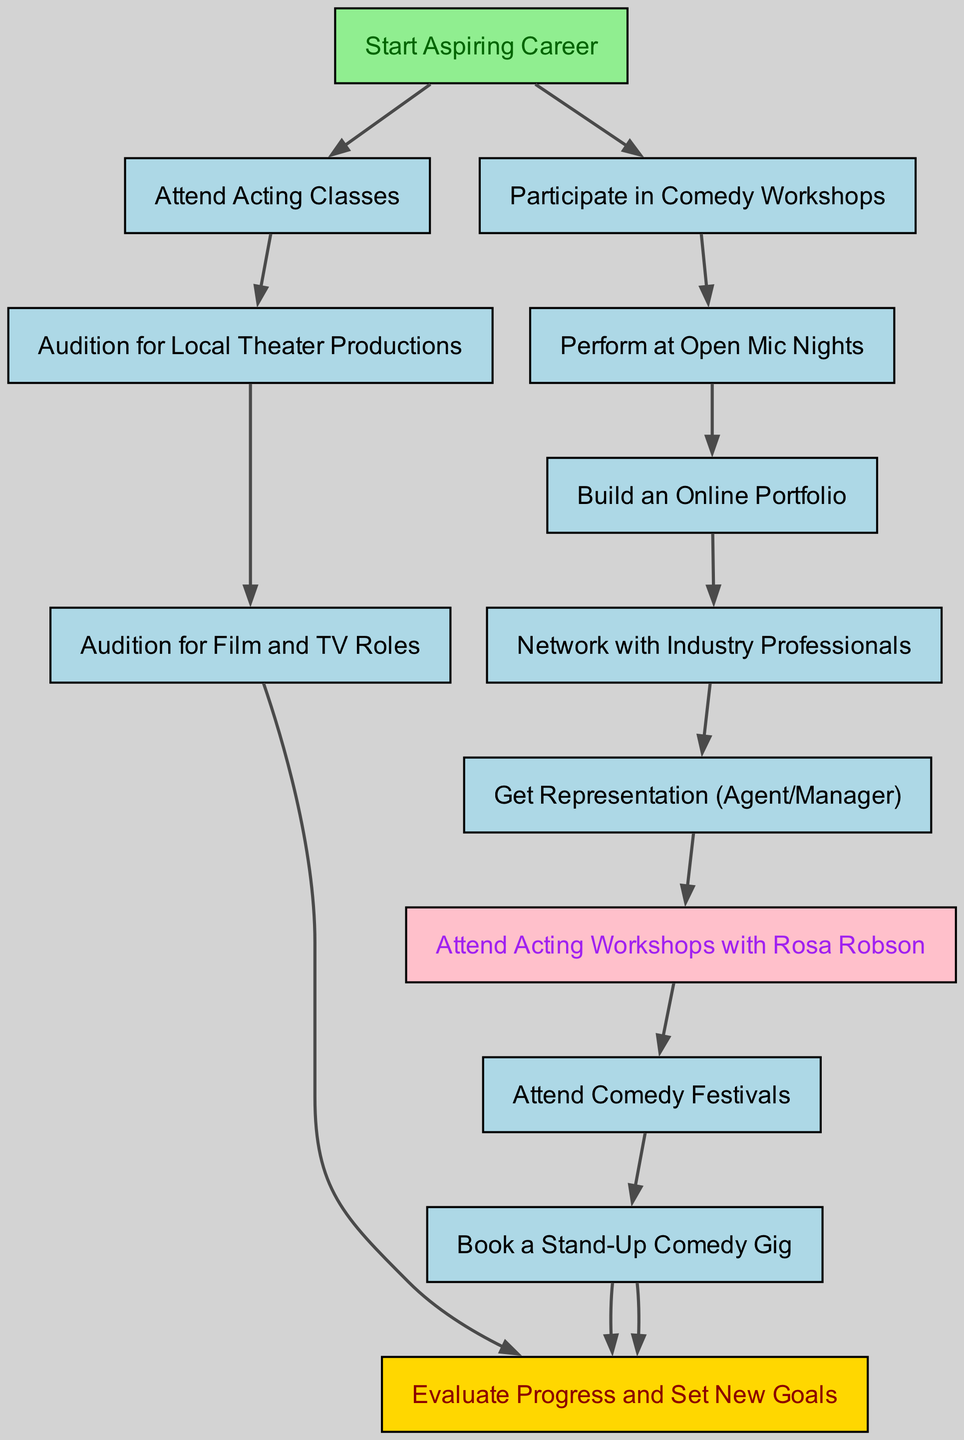What is the starting point of the career path? The diagram begins with the node labeled "Start Aspiring Career", which represents the initial step in the career path visualization.
Answer: Start Aspiring Career How many total nodes are in the diagram? By counting each unique node listed in the diagram, there are 13 distinct nodes representing different milestones and goals.
Answer: 13 What milestone follows attending acting classes? The flow from the "Attend Acting Classes" node leads to the "Audition for Local Theater Productions" node, indicating the next action after taking acting classes.
Answer: Audition for Local Theater Productions What connection exists between auditioning for local theater productions and film/TV roles? The diagram shows a directed edge from "Audition for Local Theater Productions" to "Audition for Film and TV Roles," indicating that successes in theater auditions can lead to opportunities in film and television.
Answer: Audition for Film and TV Roles Which milestone is associated with Rosa Robson? The diagram links the "Get Representation (Agent/Manager)" node to the "Attend Acting Workshops with Rosa Robson" node, suggesting that representation can facilitate access to workshops with Rosa Robson as a significant training opportunity.
Answer: Attend Acting Workshops with Rosa Robson What is the final milestone outlined in the flow chart? The terminal point of the flow chart is the "Evaluate Progress and Set New Goals," which concludes the initial career path exploration and indicates a loop back to reassessing one's journey.
Answer: Evaluate Progress and Set New Goals After performing at open mic nights, what is the next suggested action? From "Perform at Open Mic Nights," the flow moves to "Build an Online Portfolio," suggesting that showcasing performances online is encouraged after this milestone.
Answer: Build an Online Portfolio How many edges connect the nodes in this diagram? Counting all the connections (or arrows) between the nodes results in a total of 13 edges that illustrate the pathways from one milestone to another.
Answer: 13 What is the significance of the "Book a Stand-Up Comedy Gig" node? This node follows directly from "Attend Comedy Festivals," indicating that participating in festivals can lead to opportunities for booking gigs, representing progress in a comedian's career path.
Answer: Book a Stand-Up Comedy Gig What connection exists between networking and getting representation? The flow chart shows that "Network with Industry Professionals" is a prerequisite to "Get Representation (Agent/Manager)," indicating that building connections is vital for obtaining an agent or manager.
Answer: Get Representation (Agent/Manager) 